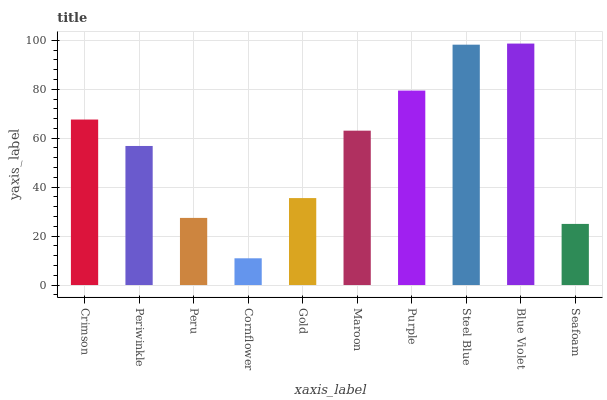Is Cornflower the minimum?
Answer yes or no. Yes. Is Blue Violet the maximum?
Answer yes or no. Yes. Is Periwinkle the minimum?
Answer yes or no. No. Is Periwinkle the maximum?
Answer yes or no. No. Is Crimson greater than Periwinkle?
Answer yes or no. Yes. Is Periwinkle less than Crimson?
Answer yes or no. Yes. Is Periwinkle greater than Crimson?
Answer yes or no. No. Is Crimson less than Periwinkle?
Answer yes or no. No. Is Maroon the high median?
Answer yes or no. Yes. Is Periwinkle the low median?
Answer yes or no. Yes. Is Gold the high median?
Answer yes or no. No. Is Seafoam the low median?
Answer yes or no. No. 